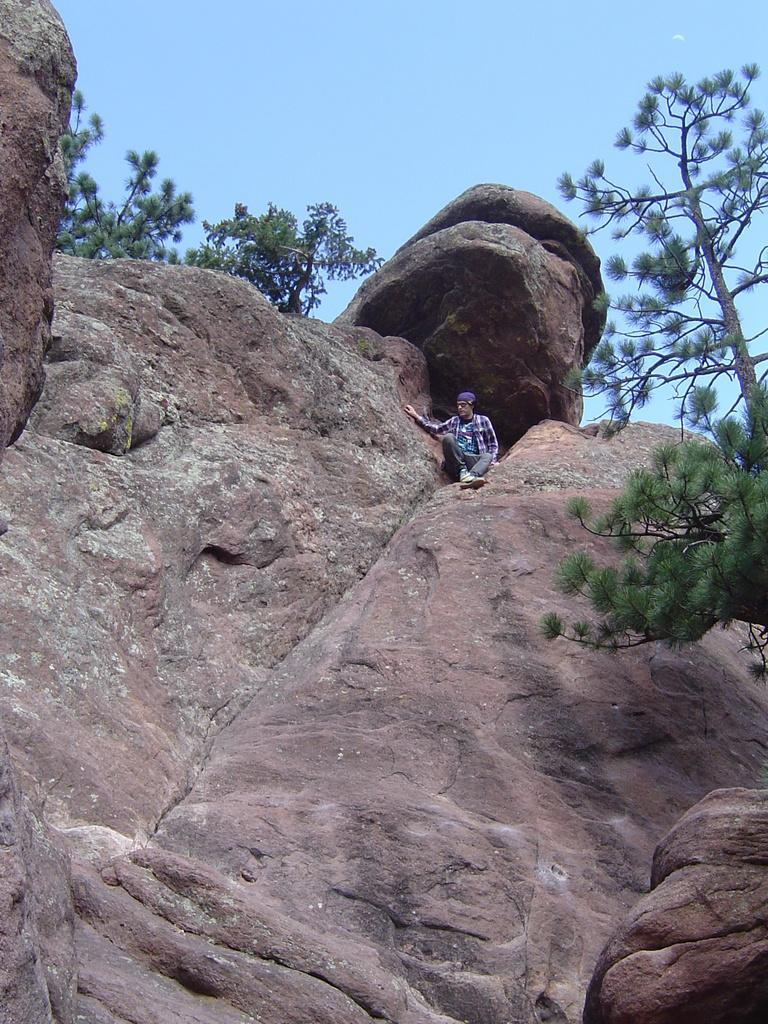What is the person in the image doing? The person is on a rock in the image. What type of vegetation can be seen in the image? There are trees in the image. What color is the sky in the image? The sky is blue in the image. What type of oil can be seen dripping from the trees in the image? There is no oil present in the image; it features a person on a rock with trees and a blue sky. 